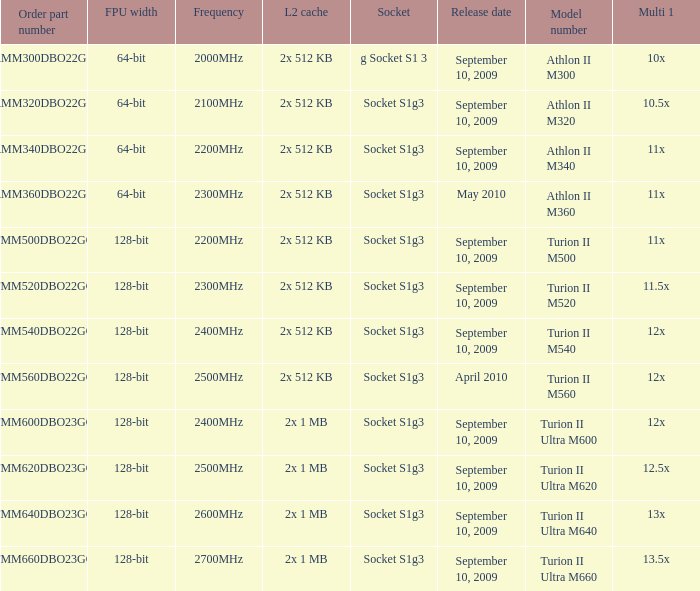What is the frequency of the tmm500dbo22gq order part number? 2200MHz. 